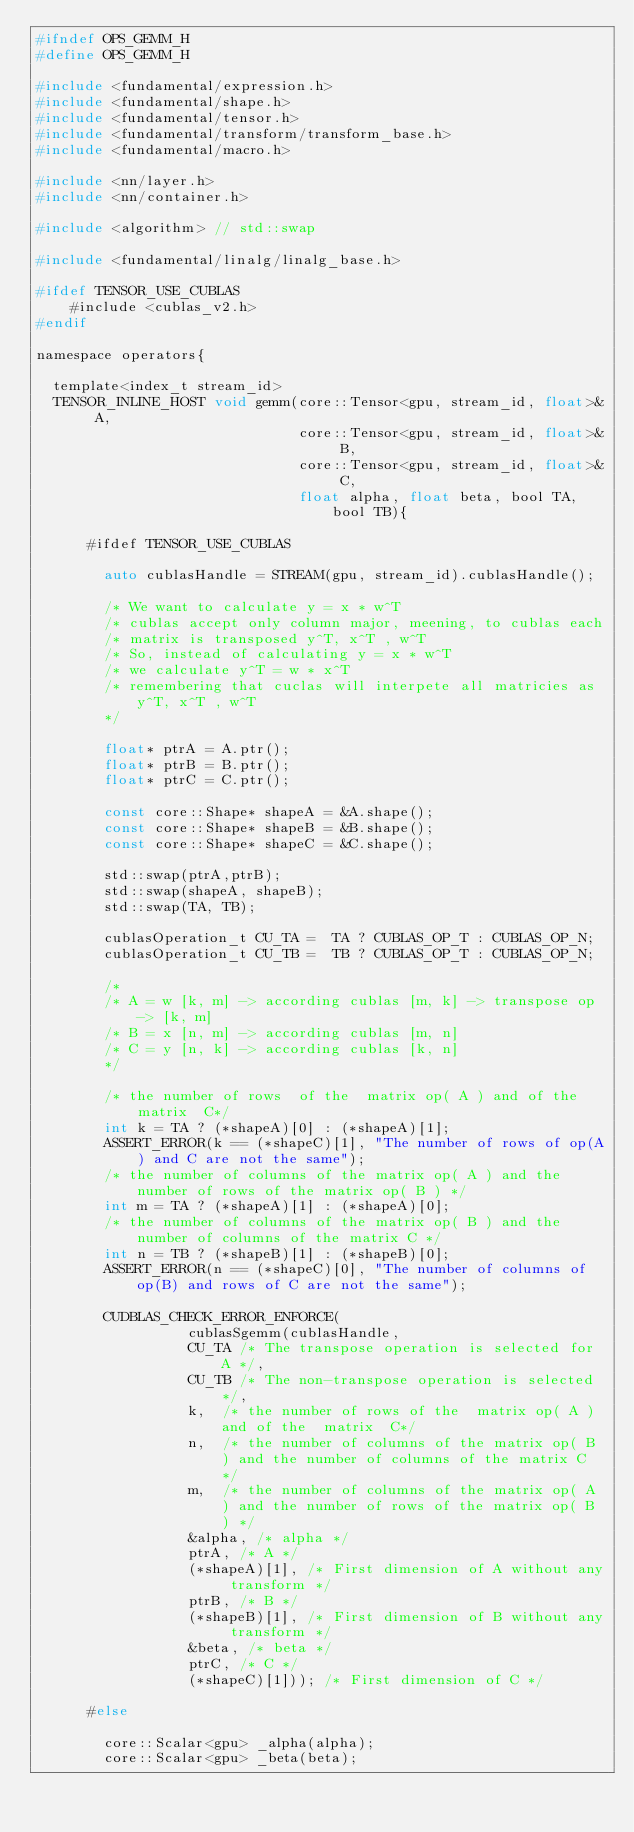<code> <loc_0><loc_0><loc_500><loc_500><_C_>#ifndef OPS_GEMM_H
#define OPS_GEMM_H

#include <fundamental/expression.h>
#include <fundamental/shape.h>
#include <fundamental/tensor.h>
#include <fundamental/transform/transform_base.h>
#include <fundamental/macro.h>

#include <nn/layer.h>
#include <nn/container.h>

#include <algorithm> // std::swap

#include <fundamental/linalg/linalg_base.h>

#ifdef TENSOR_USE_CUBLAS
    #include <cublas_v2.h>
#endif

namespace operators{

  template<index_t stream_id>
  TENSOR_INLINE_HOST void gemm(core::Tensor<gpu, stream_id, float>& A,
                               core::Tensor<gpu, stream_id, float>& B,
                               core::Tensor<gpu, stream_id, float>& C,
                               float alpha, float beta, bool TA, bool TB){

      #ifdef TENSOR_USE_CUBLAS

        auto cublasHandle = STREAM(gpu, stream_id).cublasHandle();

        /* We want to calculate y = x * w^T
        /* cublas accept only column major, meening, to cublas each
        /* matrix is transposed y^T, x^T , w^T
        /* So, instead of calculating y = x * w^T
        /* we calculate y^T = w * x^T
        /* remembering that cuclas will interpete all matricies as y^T, x^T , w^T
        */

        float* ptrA = A.ptr();
        float* ptrB = B.ptr();
        float* ptrC = C.ptr();

        const core::Shape* shapeA = &A.shape();
        const core::Shape* shapeB = &B.shape();
        const core::Shape* shapeC = &C.shape();

        std::swap(ptrA,ptrB);
        std::swap(shapeA, shapeB);
        std::swap(TA, TB);

        cublasOperation_t CU_TA =  TA ? CUBLAS_OP_T : CUBLAS_OP_N;
        cublasOperation_t CU_TB =  TB ? CUBLAS_OP_T : CUBLAS_OP_N;

        /*
        /* A = w [k, m] -> according cublas [m, k] -> transpose op -> [k, m]
        /* B = x [n, m] -> according cublas [m, n]
        /* C = y [n, k] -> according cublas [k, n]
        */

        /* the number of rows  of the  matrix op( A ) and of the  matrix  C*/
        int k = TA ? (*shapeA)[0] : (*shapeA)[1];
        ASSERT_ERROR(k == (*shapeC)[1], "The number of rows of op(A) and C are not the same");
        /* the number of columns of the matrix op( A ) and the number of rows of the matrix op( B ) */
        int m = TA ? (*shapeA)[1] : (*shapeA)[0];
        /* the number of columns of the matrix op( B ) and the number of columns of the matrix C */
        int n = TB ? (*shapeB)[1] : (*shapeB)[0];
        ASSERT_ERROR(n == (*shapeC)[0], "The number of columns of op(B) and rows of C are not the same");

        CUDBLAS_CHECK_ERROR_ENFORCE(
                  cublasSgemm(cublasHandle,
                  CU_TA /* The transpose operation is selected for A */,
                  CU_TB /* The non-transpose operation is selected */,
                  k,  /* the number of rows of the  matrix op( A ) and of the  matrix  C*/
                  n,  /* the number of columns of the matrix op( B ) and the number of columns of the matrix C */
                  m,  /* the number of columns of the matrix op( A ) and the number of rows of the matrix op( B ) */
                  &alpha, /* alpha */
                  ptrA, /* A */
                  (*shapeA)[1], /* First dimension of A without any transform */
                  ptrB, /* B */
                  (*shapeB)[1], /* First dimension of B without any transform */
                  &beta, /* beta */
                  ptrC, /* C */
                  (*shapeC)[1])); /* First dimension of C */

      #else

        core::Scalar<gpu> _alpha(alpha);
        core::Scalar<gpu> _beta(beta);
</code> 